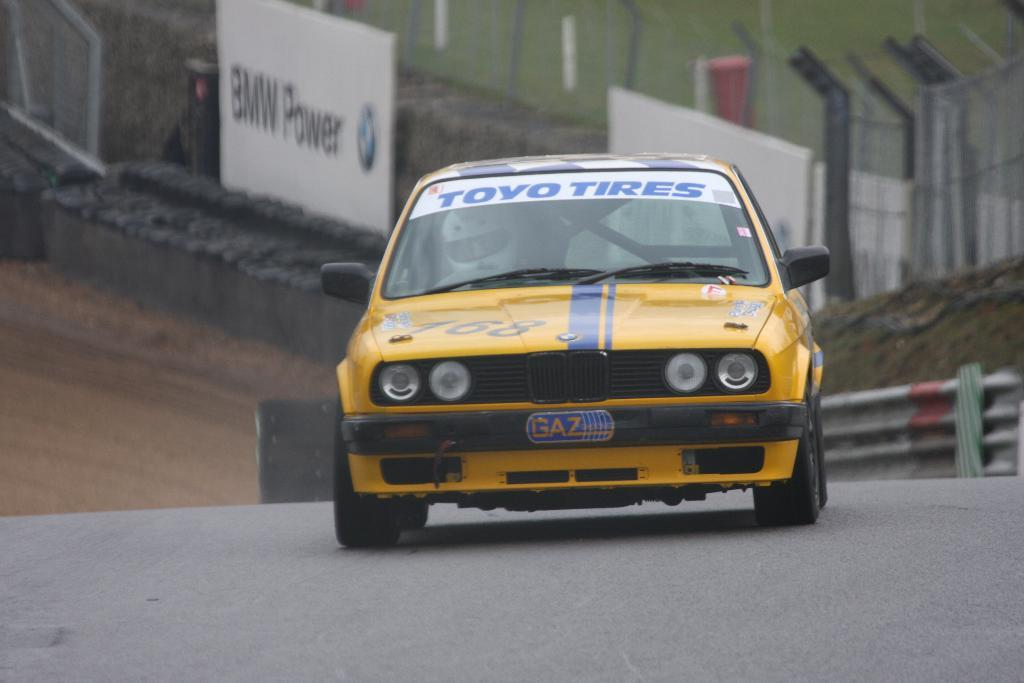What is the main subject of the image? There is a car on the road in the image. What can be seen in the background of the image? There are banners and fences in the background of the image. Are there any other objects visible in the background? Yes, there are some objects visible in the background of the image. What is the name of the person standing next to the car in the image? There is no person standing next to the car in the image. Can you tell me how many yards are visible in the image? There is no yard present in the image; it features a car on the road and objects in the background. 